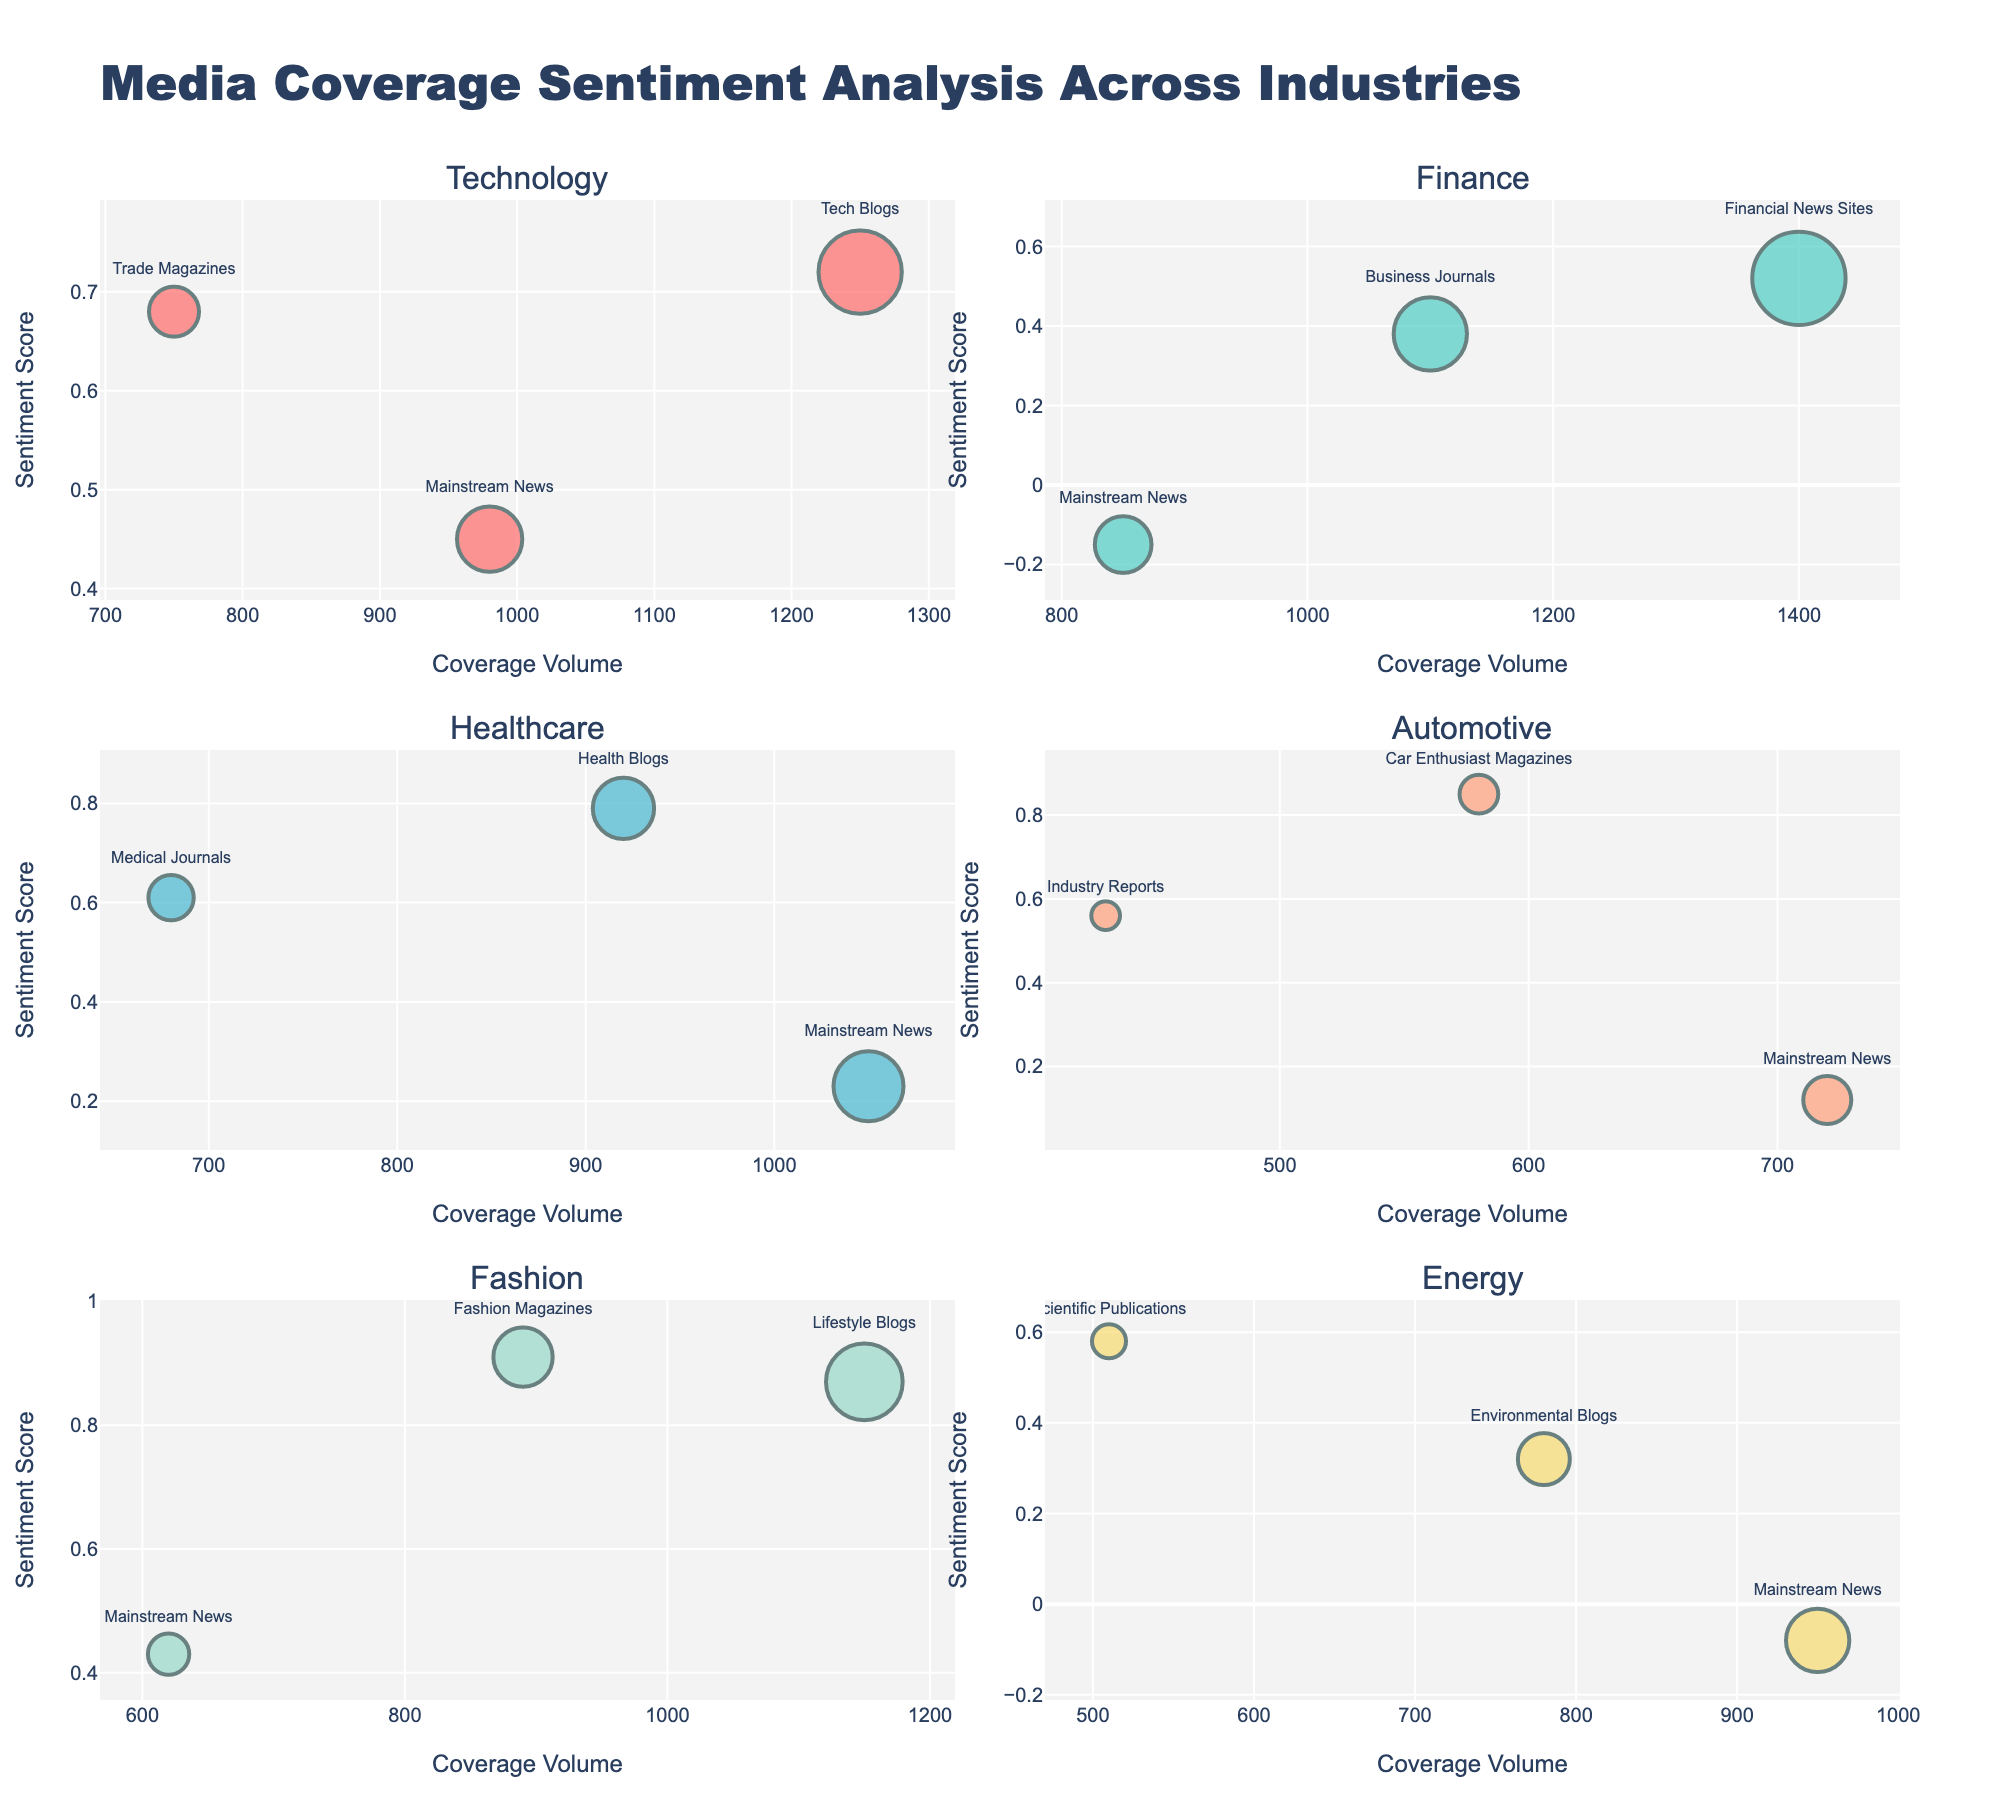What is the title of the figure? The title of the figure is prominently displayed at the top. It reads "Media Coverage Sentiment Analysis Across Industries."
Answer: Media Coverage Sentiment Analysis Across Industries Which industry has the highest sentiment score, and what is that score? By scanning through the scatter plots, identify the industry with the highest sentiment score. The Fashion industry, through Fashion Magazines, has a sentiment score of 0.91.
Answer: Fashion with a sentiment score of 0.91 How many industries show a negative sentiment score in any publication type? Look at each subplot to find any data points with a negative sentiment score. The Finance industry (Mainstream News) and the Energy industry (Mainstream News) show negative sentiment scores.
Answer: 2 What is the sentiment score for Mainstream News in the Automotive industry? Find the subplot for the Automotive industry and locate the data point for Mainstream News. The sentiment score is 0.12.
Answer: 0.12 Compare the sentiment scores for Health Blogs in the Healthcare industry and Lifestyle Blogs in the Fashion industry. Which one is higher? Locate the data points for Health Blogs in Healthcare and Lifestyle Blogs in Fashion. Health Blogs have a sentiment score of 0.79, and Lifestyle Blogs have 0.87.
Answer: Lifestyle Blogs in Fashion What is the average sentiment score for publication types in the Energy industry? Calculate the mean sentiment score for all publication types within the Energy industry. Sum the scores: 0.58 (Scientific Publications) + 0.32 (Environmental Blogs) + (-0.08) (Mainstream News) = 0.82. The average is 0.82 / 3.
Answer: 0.273 Which publication type in the Technology industry has the highest coverage volume, and what is that volume? In the Technology subplot, compare the coverage volumes for each publication type. Tech Blogs have the highest coverage volume of 1250.
Answer: Tech Blogs with 1250 How does the sentiment score for Mainstream News in the Finance industry compare to Mainstream News in the Technology industry? Locate the data points for Mainstream News in both Finance and Technology. Finance has -0.15, and Technology has 0.45. The score in Technology is higher.
Answer: Technology is higher What is the total coverage volume for all publication types within the Healthcare industry? Add up the coverage volumes for Medical Journals, Health Blogs, and Mainstream News in Healthcare. 680 + 920 + 1050 = 2650.
Answer: 2650 For which industry-publication type pair is the sentiment score closest to zero? Scan all subplots to identify the data point whose sentiment score is closest to zero. Mainstream News in the Automotive industry has a sentiment score of 0.12, the closest to zero among the given data points.
Answer: Mainstream News in Automotive 